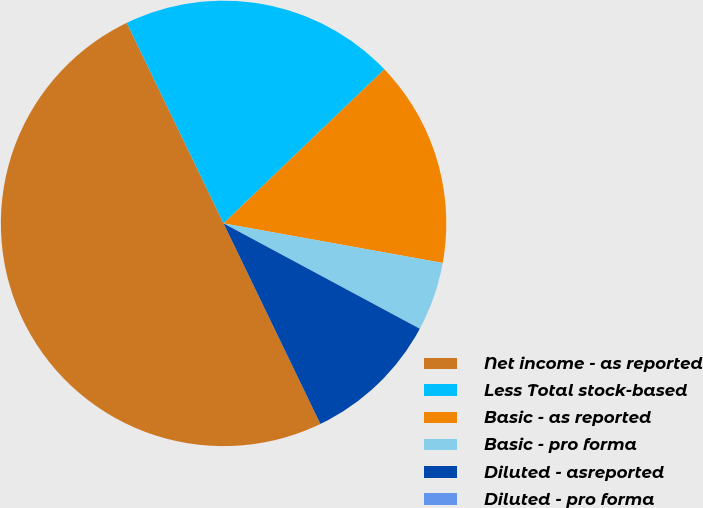Convert chart. <chart><loc_0><loc_0><loc_500><loc_500><pie_chart><fcel>Net income - as reported<fcel>Less Total stock-based<fcel>Basic - as reported<fcel>Basic - pro forma<fcel>Diluted - asreported<fcel>Diluted - pro forma<nl><fcel>50.0%<fcel>20.0%<fcel>15.0%<fcel>5.0%<fcel>10.0%<fcel>0.0%<nl></chart> 